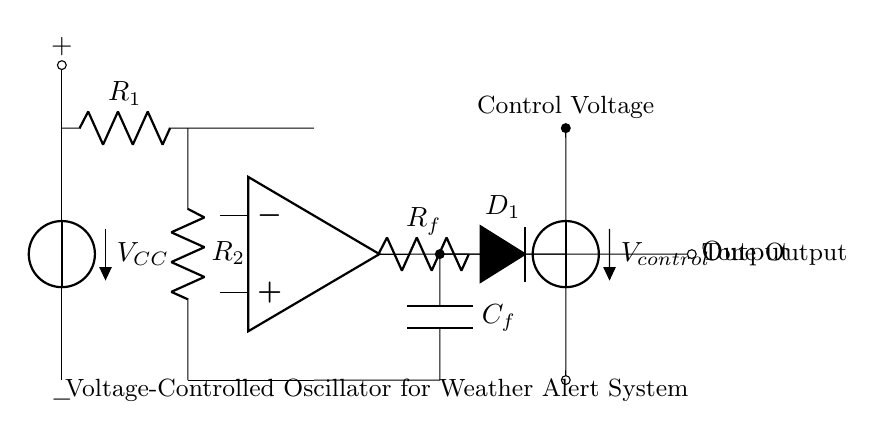What is the output of the VCO circuit? The output is indicated at the right side of the diagram, labeled as "Tone Output." This represents the signal generated by the voltage-controlled oscillator.
Answer: Tone Output What component controls frequency in this circuit? The frequency is controlled by the varactor diode labeled D1. The capacitance of the varactor changes with the control voltage, which in turn affects the frequency output of the oscillator.
Answer: D1 What is the purpose of the operational amplifier in this circuit? The operational amplifier (op amp) amplifies the input signal and is essential in generating the oscillation needed for tone production. It forms a key part of the feedback network that stabilizes the oscillation.
Answer: Amplification What is the value of VCC in the circuit? The value of VCC is not specified in the diagram, but it is typically a positive voltage supply necessary for the circuit's operation. It could generally be a common value like 5 volts or more depending on the circuit design requirements.
Answer: Not specified How does the control voltage affect the circuit? The control voltage (V_control) directly influences the capacitance of the varactor diode D1. This, combined with the feedback components, alters the frequency of the output tone generated by the oscillator.
Answer: Changes frequency Which components form the feedback network in the circuit? The feedback network is built using resistor Rf and capacitor Cf, which are connected between the output of the op amp and its inverting input. This configuration is essential for oscillations to occur.
Answer: Rf and Cf 